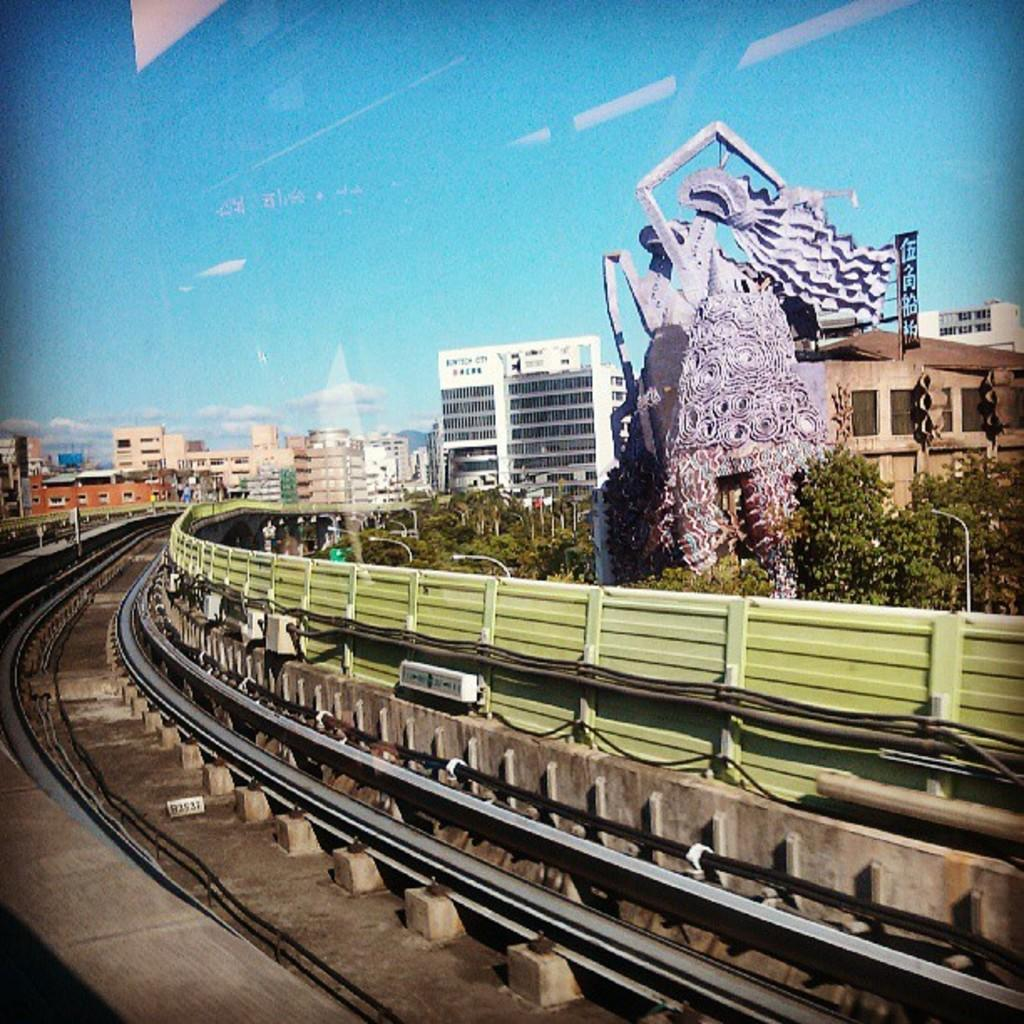What is the main subject in the image? There is a statue in the image. What can be seen surrounding the statue? There is a fence in the image. What type of transportation infrastructure is visible in the image? Railway tracks are visible in the image. What type of vegetation is present in the image? There are trees in the image. What type of lighting is present in the image? Street lights are present in the image. What type of man-made structures are visible in the image? There are buildings in the image. What is visible in the background of the image? The sky is visible in the background of the image. Is there a volcano erupting in the image? No, there is no volcano present in the image. What type of wood is used to construct the statue in the image? The statue is not made of wood; it is a different material. 